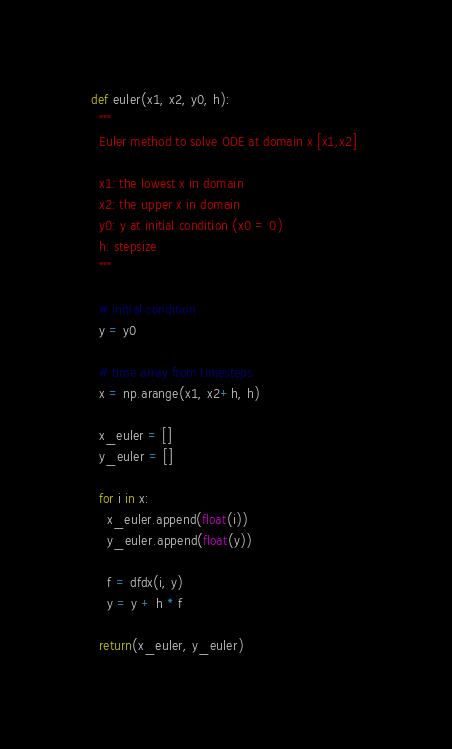Convert code to text. <code><loc_0><loc_0><loc_500><loc_500><_Python_>def euler(x1, x2, y0, h):
  """
  Euler method to solve ODE at domain x [x1,x2] 
  
  x1: the lowest x in domain
  x2: the upper x in domain
  y0: y at initial condition (x0 = 0)
  h: stepsize
  """

  # initial condition
  y = y0

  # time array from timesteps
  x = np.arange(x1, x2+h, h)

  x_euler = []
  y_euler = []

  for i in x:
    x_euler.append(float(i))
    y_euler.append(float(y))

    f = dfdx(i, y)
    y = y + h * f

  return(x_euler, y_euler)
</code> 